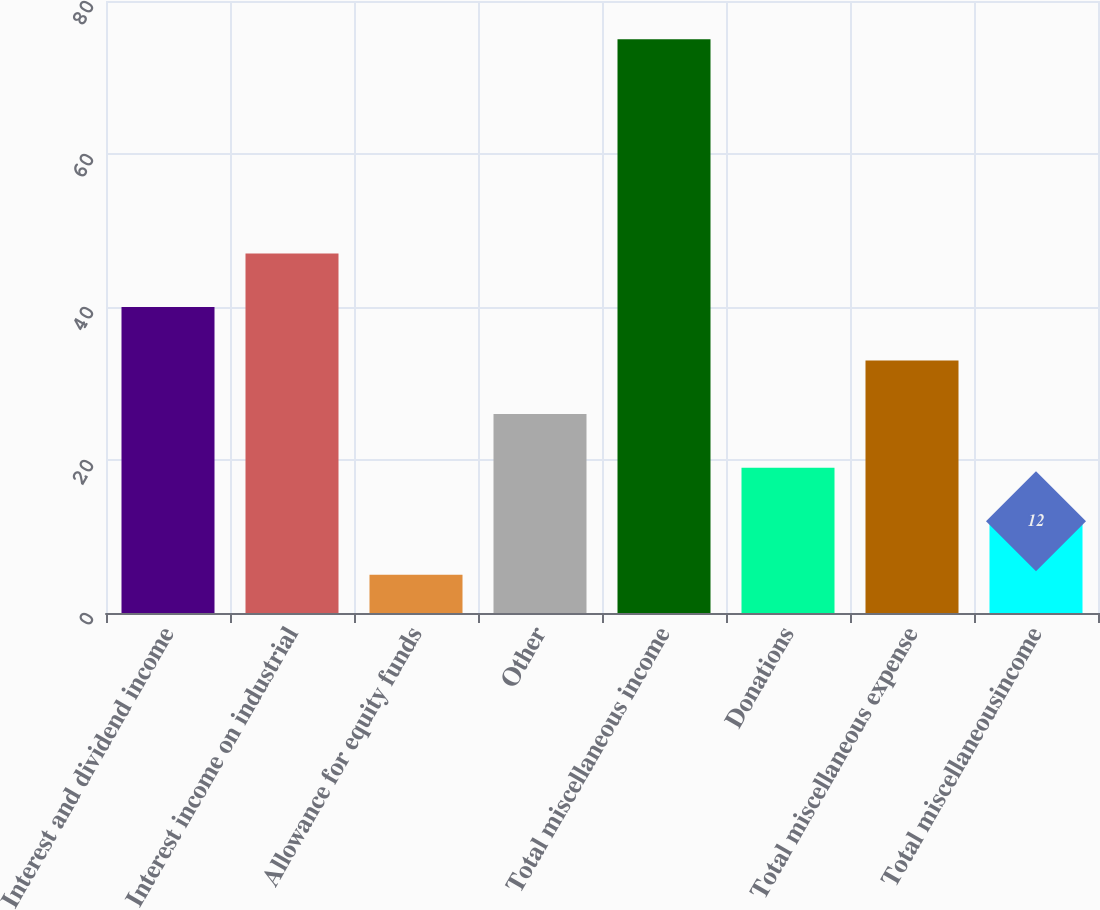Convert chart to OTSL. <chart><loc_0><loc_0><loc_500><loc_500><bar_chart><fcel>Interest and dividend income<fcel>Interest income on industrial<fcel>Allowance for equity funds<fcel>Other<fcel>Total miscellaneous income<fcel>Donations<fcel>Total miscellaneous expense<fcel>Total miscellaneousincome<nl><fcel>40<fcel>47<fcel>5<fcel>26<fcel>75<fcel>19<fcel>33<fcel>12<nl></chart> 